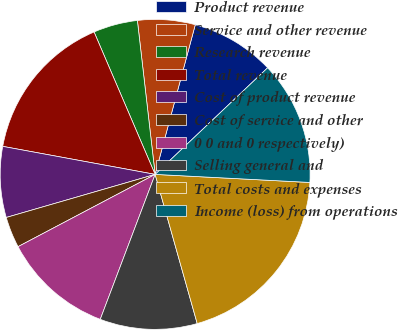Convert chart. <chart><loc_0><loc_0><loc_500><loc_500><pie_chart><fcel>Product revenue<fcel>Service and other revenue<fcel>Research revenue<fcel>Total revenue<fcel>Cost of product revenue<fcel>Cost of service and other<fcel>0 0 and 0 respectively)<fcel>Selling general and<fcel>Total costs and expenses<fcel>Income (loss) from operations<nl><fcel>8.76%<fcel>6.0%<fcel>4.62%<fcel>15.66%<fcel>7.38%<fcel>3.24%<fcel>11.52%<fcel>10.14%<fcel>19.8%<fcel>12.9%<nl></chart> 